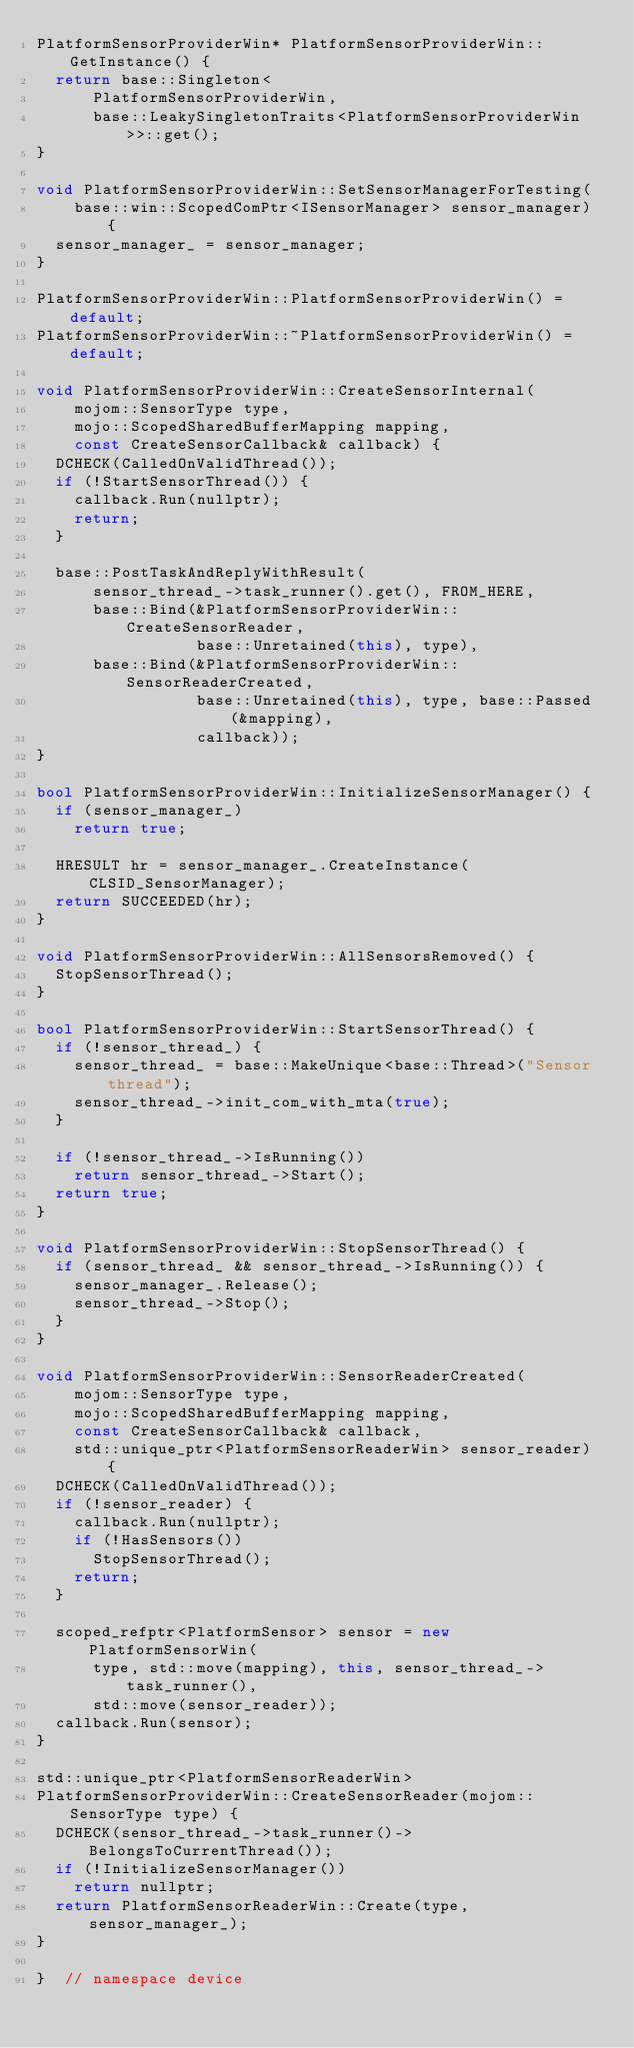<code> <loc_0><loc_0><loc_500><loc_500><_C++_>PlatformSensorProviderWin* PlatformSensorProviderWin::GetInstance() {
  return base::Singleton<
      PlatformSensorProviderWin,
      base::LeakySingletonTraits<PlatformSensorProviderWin>>::get();
}

void PlatformSensorProviderWin::SetSensorManagerForTesting(
    base::win::ScopedComPtr<ISensorManager> sensor_manager) {
  sensor_manager_ = sensor_manager;
}

PlatformSensorProviderWin::PlatformSensorProviderWin() = default;
PlatformSensorProviderWin::~PlatformSensorProviderWin() = default;

void PlatformSensorProviderWin::CreateSensorInternal(
    mojom::SensorType type,
    mojo::ScopedSharedBufferMapping mapping,
    const CreateSensorCallback& callback) {
  DCHECK(CalledOnValidThread());
  if (!StartSensorThread()) {
    callback.Run(nullptr);
    return;
  }

  base::PostTaskAndReplyWithResult(
      sensor_thread_->task_runner().get(), FROM_HERE,
      base::Bind(&PlatformSensorProviderWin::CreateSensorReader,
                 base::Unretained(this), type),
      base::Bind(&PlatformSensorProviderWin::SensorReaderCreated,
                 base::Unretained(this), type, base::Passed(&mapping),
                 callback));
}

bool PlatformSensorProviderWin::InitializeSensorManager() {
  if (sensor_manager_)
    return true;

  HRESULT hr = sensor_manager_.CreateInstance(CLSID_SensorManager);
  return SUCCEEDED(hr);
}

void PlatformSensorProviderWin::AllSensorsRemoved() {
  StopSensorThread();
}

bool PlatformSensorProviderWin::StartSensorThread() {
  if (!sensor_thread_) {
    sensor_thread_ = base::MakeUnique<base::Thread>("Sensor thread");
    sensor_thread_->init_com_with_mta(true);
  }

  if (!sensor_thread_->IsRunning())
    return sensor_thread_->Start();
  return true;
}

void PlatformSensorProviderWin::StopSensorThread() {
  if (sensor_thread_ && sensor_thread_->IsRunning()) {
    sensor_manager_.Release();
    sensor_thread_->Stop();
  }
}

void PlatformSensorProviderWin::SensorReaderCreated(
    mojom::SensorType type,
    mojo::ScopedSharedBufferMapping mapping,
    const CreateSensorCallback& callback,
    std::unique_ptr<PlatformSensorReaderWin> sensor_reader) {
  DCHECK(CalledOnValidThread());
  if (!sensor_reader) {
    callback.Run(nullptr);
    if (!HasSensors())
      StopSensorThread();
    return;
  }

  scoped_refptr<PlatformSensor> sensor = new PlatformSensorWin(
      type, std::move(mapping), this, sensor_thread_->task_runner(),
      std::move(sensor_reader));
  callback.Run(sensor);
}

std::unique_ptr<PlatformSensorReaderWin>
PlatformSensorProviderWin::CreateSensorReader(mojom::SensorType type) {
  DCHECK(sensor_thread_->task_runner()->BelongsToCurrentThread());
  if (!InitializeSensorManager())
    return nullptr;
  return PlatformSensorReaderWin::Create(type, sensor_manager_);
}

}  // namespace device
</code> 